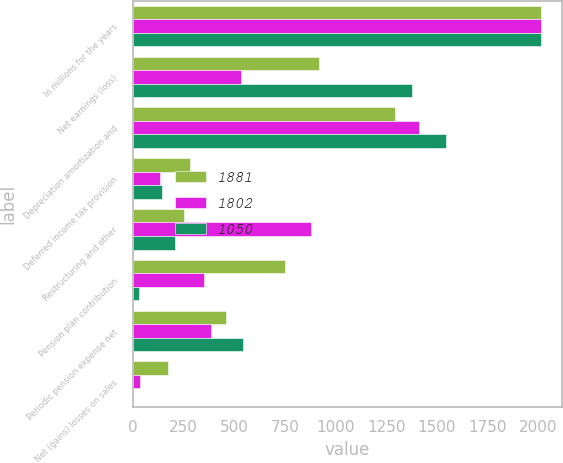Convert chart to OTSL. <chart><loc_0><loc_0><loc_500><loc_500><stacked_bar_chart><ecel><fcel>In millions for the years<fcel>Net earnings (loss)<fcel>Depreciation amortization and<fcel>Deferred income tax provision<fcel>Restructuring and other<fcel>Pension plan contribution<fcel>Periodic pension expense net<fcel>Net (gains) losses on sales<nl><fcel>1881<fcel>2015<fcel>917<fcel>1294<fcel>281<fcel>252<fcel>750<fcel>461<fcel>174<nl><fcel>1802<fcel>2014<fcel>536<fcel>1414<fcel>135<fcel>881<fcel>353<fcel>387<fcel>38<nl><fcel>1050<fcel>2013<fcel>1378<fcel>1547<fcel>146<fcel>210<fcel>31<fcel>545<fcel>3<nl></chart> 